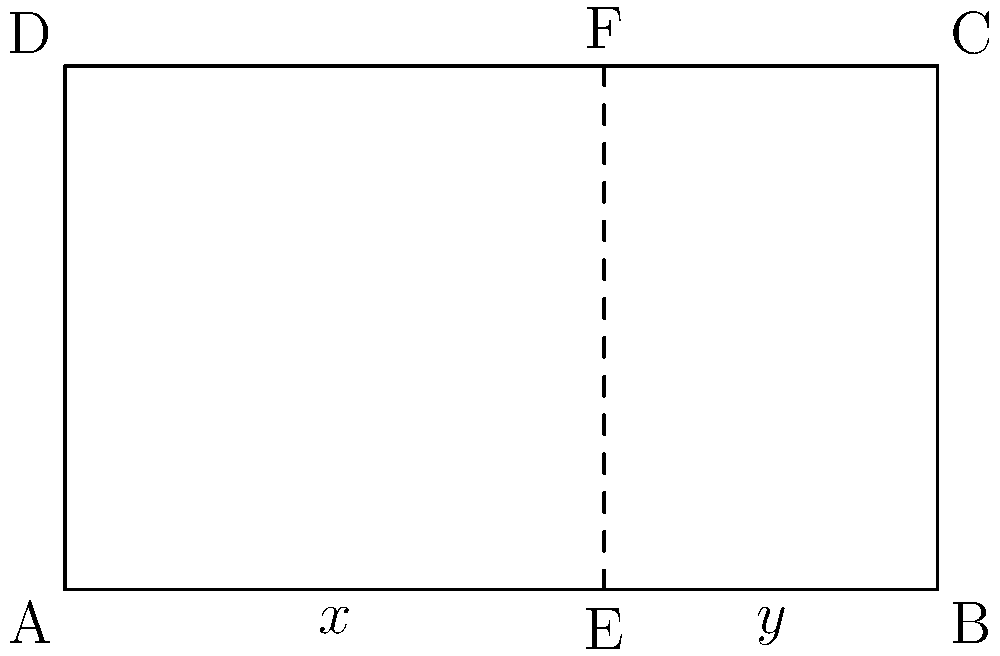In the rectangular representation of an Armenian manuscript page, the golden ratio is applied to divide the width. If the total width of the page is 5 units, what is the value of $x$ in the diagram, rounded to two decimal places? To find the value of $x$, we need to follow these steps:

1. Recall that the golden ratio is approximately 1.618 or its inverse, 0.618.

2. In this diagram, the total width (5 units) is divided according to the golden ratio.

3. The larger segment $y$ corresponds to the golden ratio (0.618) of the total width:
   $y = 5 * 0.618 = 3.09$ units

4. The smaller segment $x$ is the remainder of the total width:
   $x = 5 - y = 5 - 3.09 = 1.91$ units

5. Rounding to two decimal places, we get 1.91 units.

This division represents how Armenian manuscript illuminators might have used the golden ratio in their page layouts, demonstrating the influence of European aesthetic principles on Armenian manuscript art.
Answer: 1.91 units 